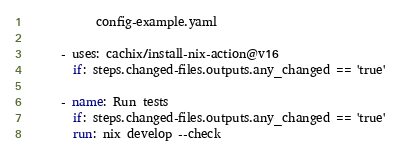<code> <loc_0><loc_0><loc_500><loc_500><_YAML_>            config-example.yaml

      - uses: cachix/install-nix-action@v16
        if: steps.changed-files.outputs.any_changed == 'true'

      - name: Run tests
        if: steps.changed-files.outputs.any_changed == 'true'
        run: nix develop --check
</code> 